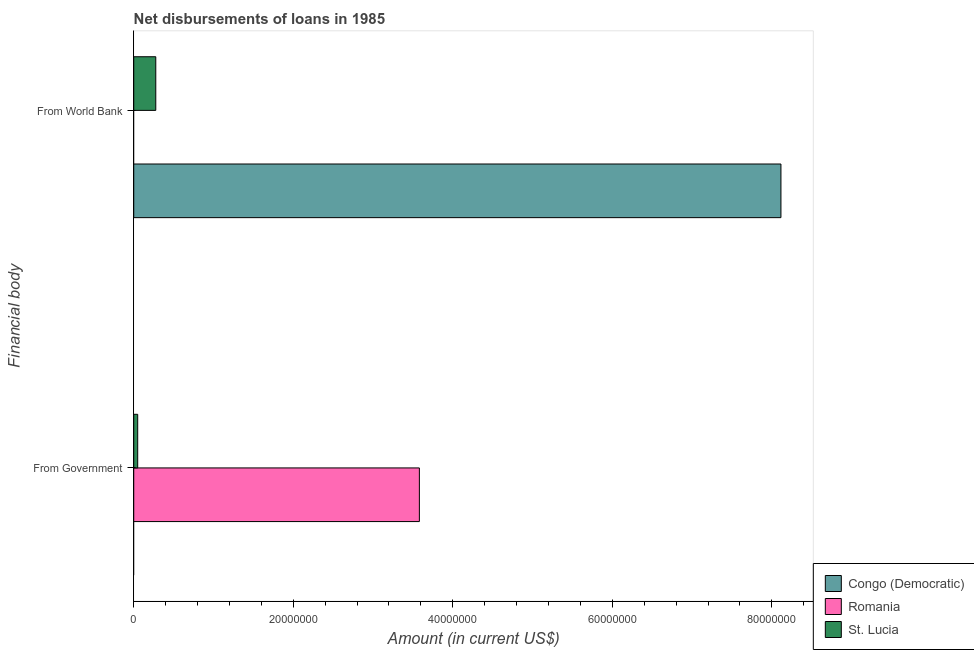How many groups of bars are there?
Ensure brevity in your answer.  2. How many bars are there on the 1st tick from the top?
Give a very brief answer. 2. How many bars are there on the 1st tick from the bottom?
Ensure brevity in your answer.  2. What is the label of the 1st group of bars from the top?
Your answer should be compact. From World Bank. What is the net disbursements of loan from government in Congo (Democratic)?
Give a very brief answer. 0. Across all countries, what is the maximum net disbursements of loan from world bank?
Your answer should be very brief. 8.11e+07. In which country was the net disbursements of loan from government maximum?
Offer a terse response. Romania. What is the total net disbursements of loan from government in the graph?
Give a very brief answer. 3.63e+07. What is the difference between the net disbursements of loan from world bank in Congo (Democratic) and that in St. Lucia?
Keep it short and to the point. 7.84e+07. What is the difference between the net disbursements of loan from government in St. Lucia and the net disbursements of loan from world bank in Romania?
Offer a terse response. 4.96e+05. What is the average net disbursements of loan from world bank per country?
Make the answer very short. 2.80e+07. What is the difference between the net disbursements of loan from government and net disbursements of loan from world bank in St. Lucia?
Make the answer very short. -2.27e+06. In how many countries, is the net disbursements of loan from government greater than 16000000 US$?
Ensure brevity in your answer.  1. What is the ratio of the net disbursements of loan from world bank in Congo (Democratic) to that in St. Lucia?
Give a very brief answer. 29.37. Is the net disbursements of loan from government in St. Lucia less than that in Romania?
Provide a short and direct response. Yes. In how many countries, is the net disbursements of loan from world bank greater than the average net disbursements of loan from world bank taken over all countries?
Offer a very short reply. 1. How many countries are there in the graph?
Ensure brevity in your answer.  3. What is the difference between two consecutive major ticks on the X-axis?
Provide a short and direct response. 2.00e+07. Where does the legend appear in the graph?
Provide a short and direct response. Bottom right. How many legend labels are there?
Ensure brevity in your answer.  3. How are the legend labels stacked?
Your answer should be compact. Vertical. What is the title of the graph?
Offer a very short reply. Net disbursements of loans in 1985. What is the label or title of the X-axis?
Offer a very short reply. Amount (in current US$). What is the label or title of the Y-axis?
Provide a succinct answer. Financial body. What is the Amount (in current US$) of Congo (Democratic) in From Government?
Give a very brief answer. 0. What is the Amount (in current US$) in Romania in From Government?
Your answer should be very brief. 3.58e+07. What is the Amount (in current US$) of St. Lucia in From Government?
Provide a short and direct response. 4.96e+05. What is the Amount (in current US$) in Congo (Democratic) in From World Bank?
Your answer should be compact. 8.11e+07. What is the Amount (in current US$) in Romania in From World Bank?
Your answer should be very brief. 0. What is the Amount (in current US$) of St. Lucia in From World Bank?
Your response must be concise. 2.76e+06. Across all Financial body, what is the maximum Amount (in current US$) in Congo (Democratic)?
Make the answer very short. 8.11e+07. Across all Financial body, what is the maximum Amount (in current US$) of Romania?
Keep it short and to the point. 3.58e+07. Across all Financial body, what is the maximum Amount (in current US$) in St. Lucia?
Give a very brief answer. 2.76e+06. Across all Financial body, what is the minimum Amount (in current US$) of St. Lucia?
Give a very brief answer. 4.96e+05. What is the total Amount (in current US$) of Congo (Democratic) in the graph?
Provide a succinct answer. 8.11e+07. What is the total Amount (in current US$) in Romania in the graph?
Offer a terse response. 3.58e+07. What is the total Amount (in current US$) in St. Lucia in the graph?
Offer a very short reply. 3.26e+06. What is the difference between the Amount (in current US$) in St. Lucia in From Government and that in From World Bank?
Provide a short and direct response. -2.27e+06. What is the difference between the Amount (in current US$) of Romania in From Government and the Amount (in current US$) of St. Lucia in From World Bank?
Your answer should be very brief. 3.30e+07. What is the average Amount (in current US$) of Congo (Democratic) per Financial body?
Make the answer very short. 4.06e+07. What is the average Amount (in current US$) in Romania per Financial body?
Ensure brevity in your answer.  1.79e+07. What is the average Amount (in current US$) in St. Lucia per Financial body?
Your response must be concise. 1.63e+06. What is the difference between the Amount (in current US$) in Romania and Amount (in current US$) in St. Lucia in From Government?
Provide a short and direct response. 3.53e+07. What is the difference between the Amount (in current US$) of Congo (Democratic) and Amount (in current US$) of St. Lucia in From World Bank?
Provide a succinct answer. 7.84e+07. What is the ratio of the Amount (in current US$) in St. Lucia in From Government to that in From World Bank?
Your response must be concise. 0.18. What is the difference between the highest and the second highest Amount (in current US$) of St. Lucia?
Make the answer very short. 2.27e+06. What is the difference between the highest and the lowest Amount (in current US$) in Congo (Democratic)?
Give a very brief answer. 8.11e+07. What is the difference between the highest and the lowest Amount (in current US$) in Romania?
Provide a succinct answer. 3.58e+07. What is the difference between the highest and the lowest Amount (in current US$) in St. Lucia?
Your answer should be compact. 2.27e+06. 